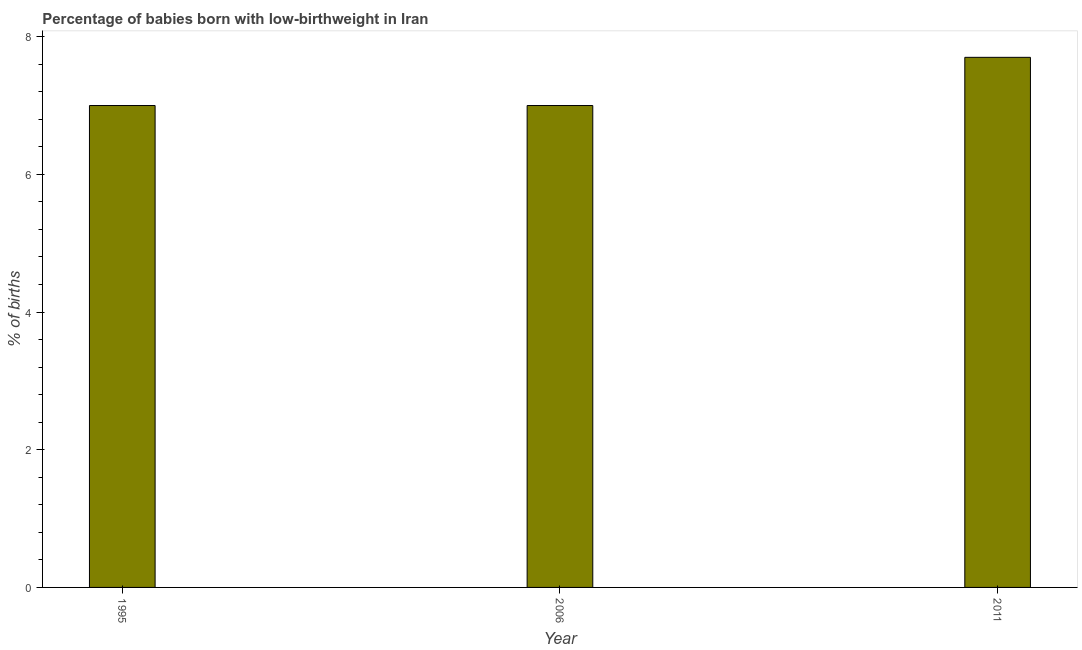Does the graph contain any zero values?
Offer a terse response. No. What is the title of the graph?
Provide a succinct answer. Percentage of babies born with low-birthweight in Iran. What is the label or title of the Y-axis?
Make the answer very short. % of births. What is the percentage of babies who were born with low-birthweight in 1995?
Your answer should be very brief. 7. Across all years, what is the maximum percentage of babies who were born with low-birthweight?
Keep it short and to the point. 7.7. Across all years, what is the minimum percentage of babies who were born with low-birthweight?
Your answer should be compact. 7. In which year was the percentage of babies who were born with low-birthweight minimum?
Keep it short and to the point. 1995. What is the sum of the percentage of babies who were born with low-birthweight?
Provide a succinct answer. 21.7. What is the average percentage of babies who were born with low-birthweight per year?
Provide a succinct answer. 7.23. What is the median percentage of babies who were born with low-birthweight?
Provide a short and direct response. 7. In how many years, is the percentage of babies who were born with low-birthweight greater than 1.6 %?
Make the answer very short. 3. Do a majority of the years between 2011 and 1995 (inclusive) have percentage of babies who were born with low-birthweight greater than 0.8 %?
Your response must be concise. Yes. What is the ratio of the percentage of babies who were born with low-birthweight in 1995 to that in 2011?
Provide a short and direct response. 0.91. What is the difference between the highest and the second highest percentage of babies who were born with low-birthweight?
Your answer should be compact. 0.7. How many bars are there?
Offer a terse response. 3. Are all the bars in the graph horizontal?
Make the answer very short. No. How many years are there in the graph?
Offer a very short reply. 3. What is the difference between two consecutive major ticks on the Y-axis?
Your answer should be compact. 2. Are the values on the major ticks of Y-axis written in scientific E-notation?
Keep it short and to the point. No. What is the % of births in 1995?
Provide a succinct answer. 7. What is the % of births of 2006?
Provide a short and direct response. 7. What is the difference between the % of births in 1995 and 2006?
Offer a terse response. 0. What is the difference between the % of births in 1995 and 2011?
Offer a terse response. -0.7. What is the difference between the % of births in 2006 and 2011?
Offer a very short reply. -0.7. What is the ratio of the % of births in 1995 to that in 2006?
Offer a very short reply. 1. What is the ratio of the % of births in 1995 to that in 2011?
Your answer should be compact. 0.91. What is the ratio of the % of births in 2006 to that in 2011?
Offer a very short reply. 0.91. 